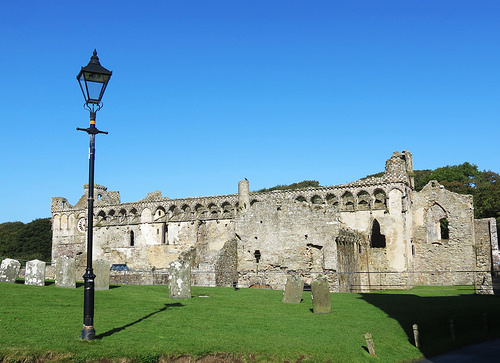<image>
Can you confirm if the sky is behind the palace? Yes. From this viewpoint, the sky is positioned behind the palace, with the palace partially or fully occluding the sky. 